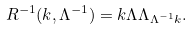<formula> <loc_0><loc_0><loc_500><loc_500>R ^ { - 1 } ( k , \Lambda ^ { - 1 } ) = \L k \Lambda \Lambda _ { \Lambda ^ { - 1 } k } \/ .</formula> 